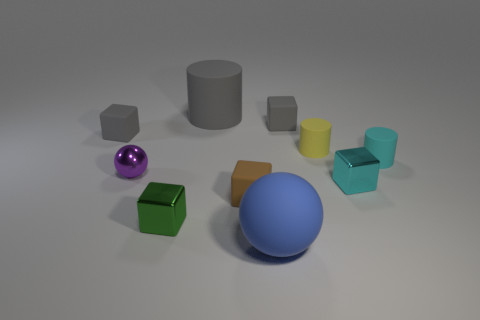Subtract 2 cubes. How many cubes are left? 3 Subtract all brown cubes. How many cubes are left? 4 Subtract all small green metallic blocks. How many blocks are left? 4 Subtract all red blocks. Subtract all cyan cylinders. How many blocks are left? 5 Subtract all cylinders. How many objects are left? 7 Add 1 tiny brown things. How many tiny brown things exist? 2 Subtract 0 blue blocks. How many objects are left? 10 Subtract all gray objects. Subtract all tiny purple metallic spheres. How many objects are left? 6 Add 6 cyan cubes. How many cyan cubes are left? 7 